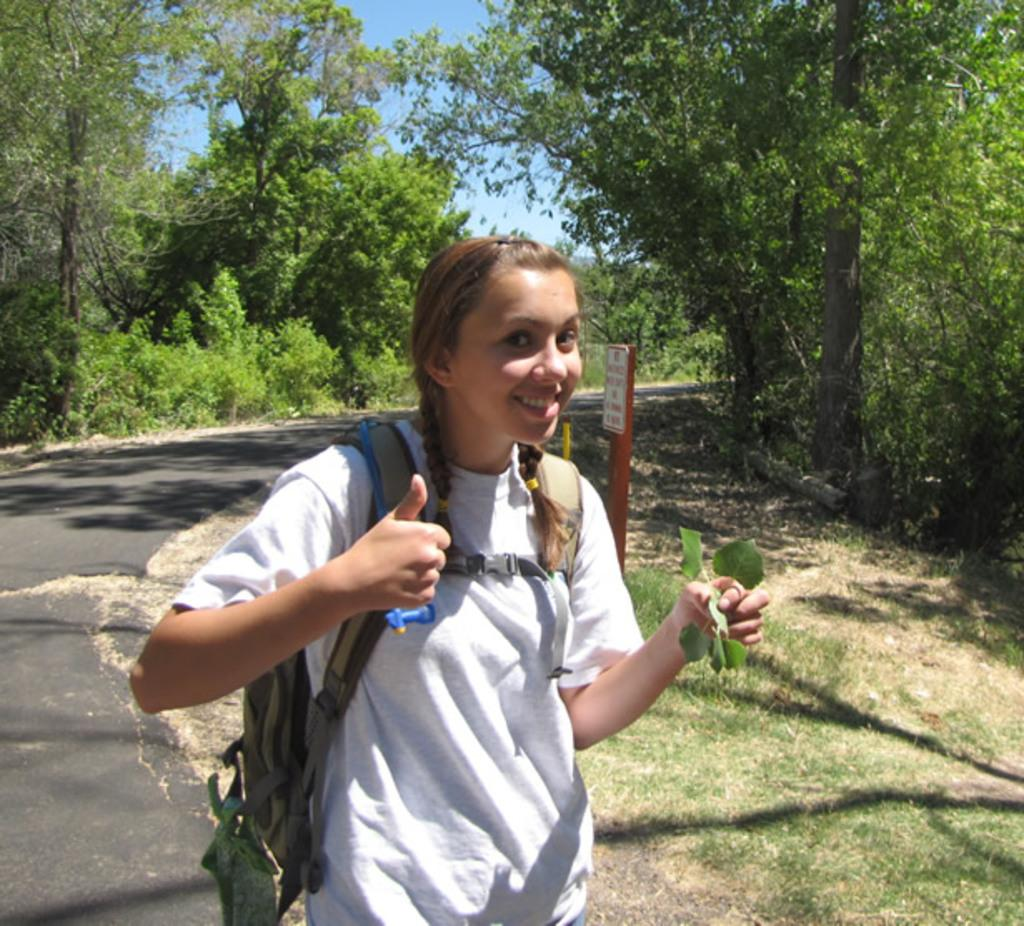What is the person in the image wearing? The person is wearing a white dress. What is the person carrying in the image? The person is carrying a bag. Where is the person located in the image? The person is on the road. What else can be seen in the image besides the person? There is a board visible in the image, as well as trees and the sky. What type of shirt is the manager wearing in the image? There is no manager present in the image, and therefore no shirt to describe. How many cattle can be seen grazing in the image? There are no cattle present in the image. 